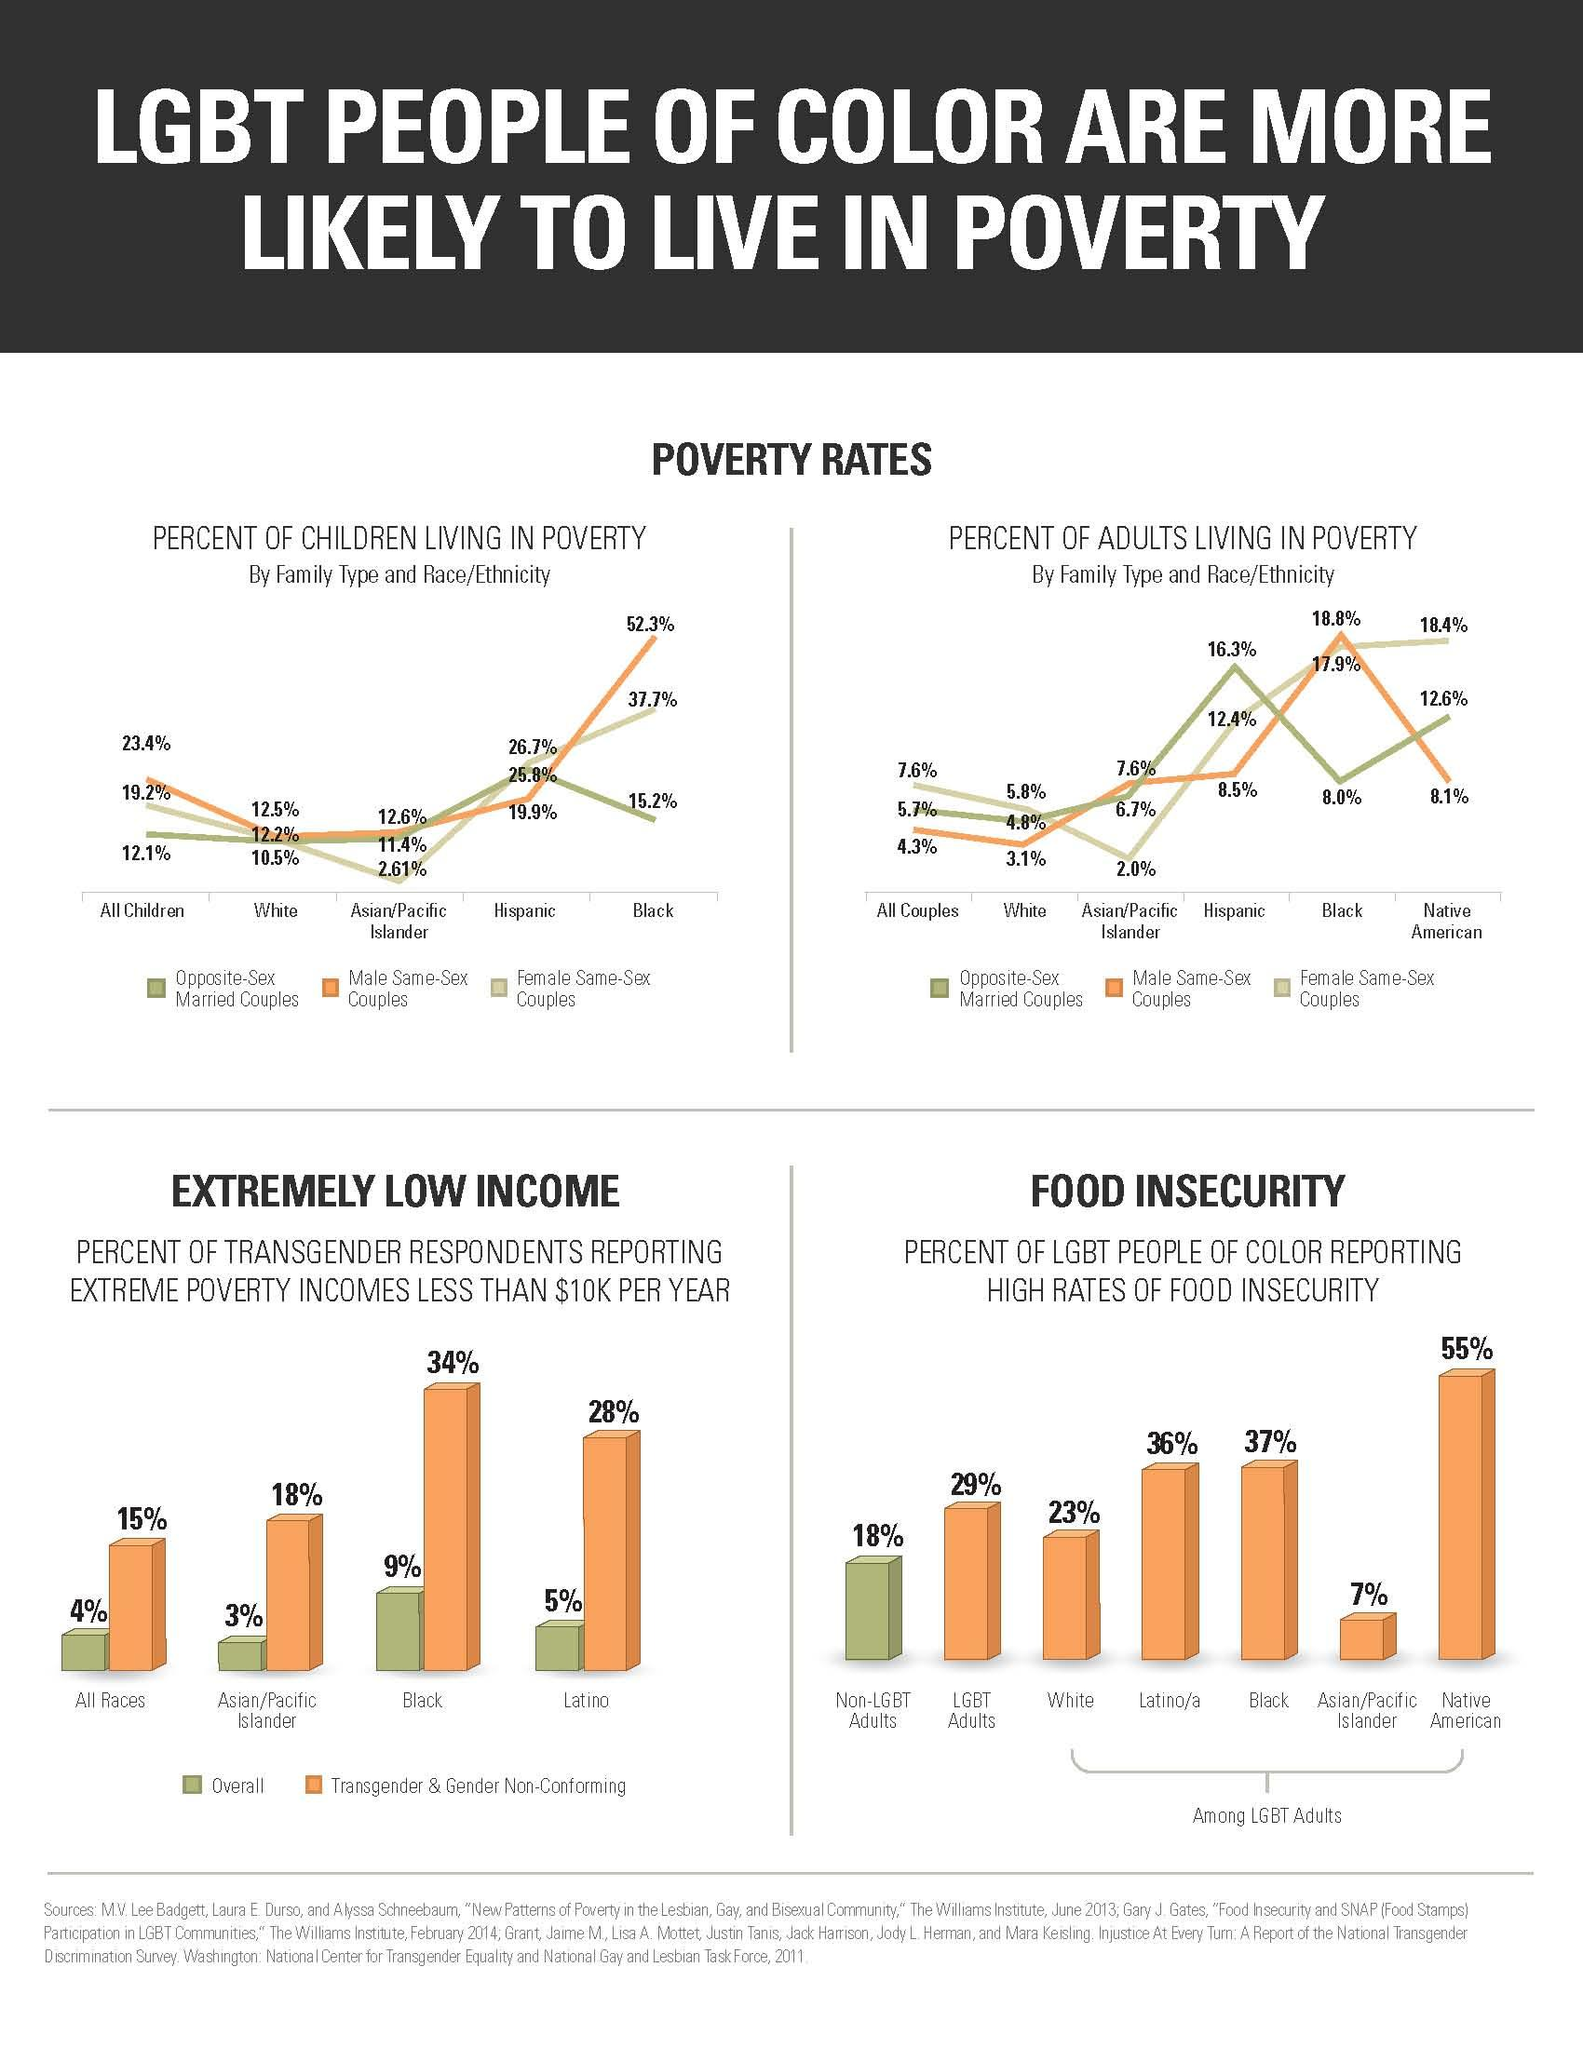Draw attention to some important aspects in this diagram. According to data, only 4.8% of white opposite-sex married couples living in poverty fall within the poverty line. LGBT adults are disproportionately affected by food insecurity, with their community ranking third in terms of higher levels of food insecurity compared to the general population. What is the difference between the overall and transgender category for the Latino community?" is a question asking for clarification on the differences between these two categories. The percentage difference in food insecurity between non-LGBT adults and whites is 5. According to the data, 19.9% of children living in poverty who are part of a Hispanic male same-sex couple fall below the poverty line. 